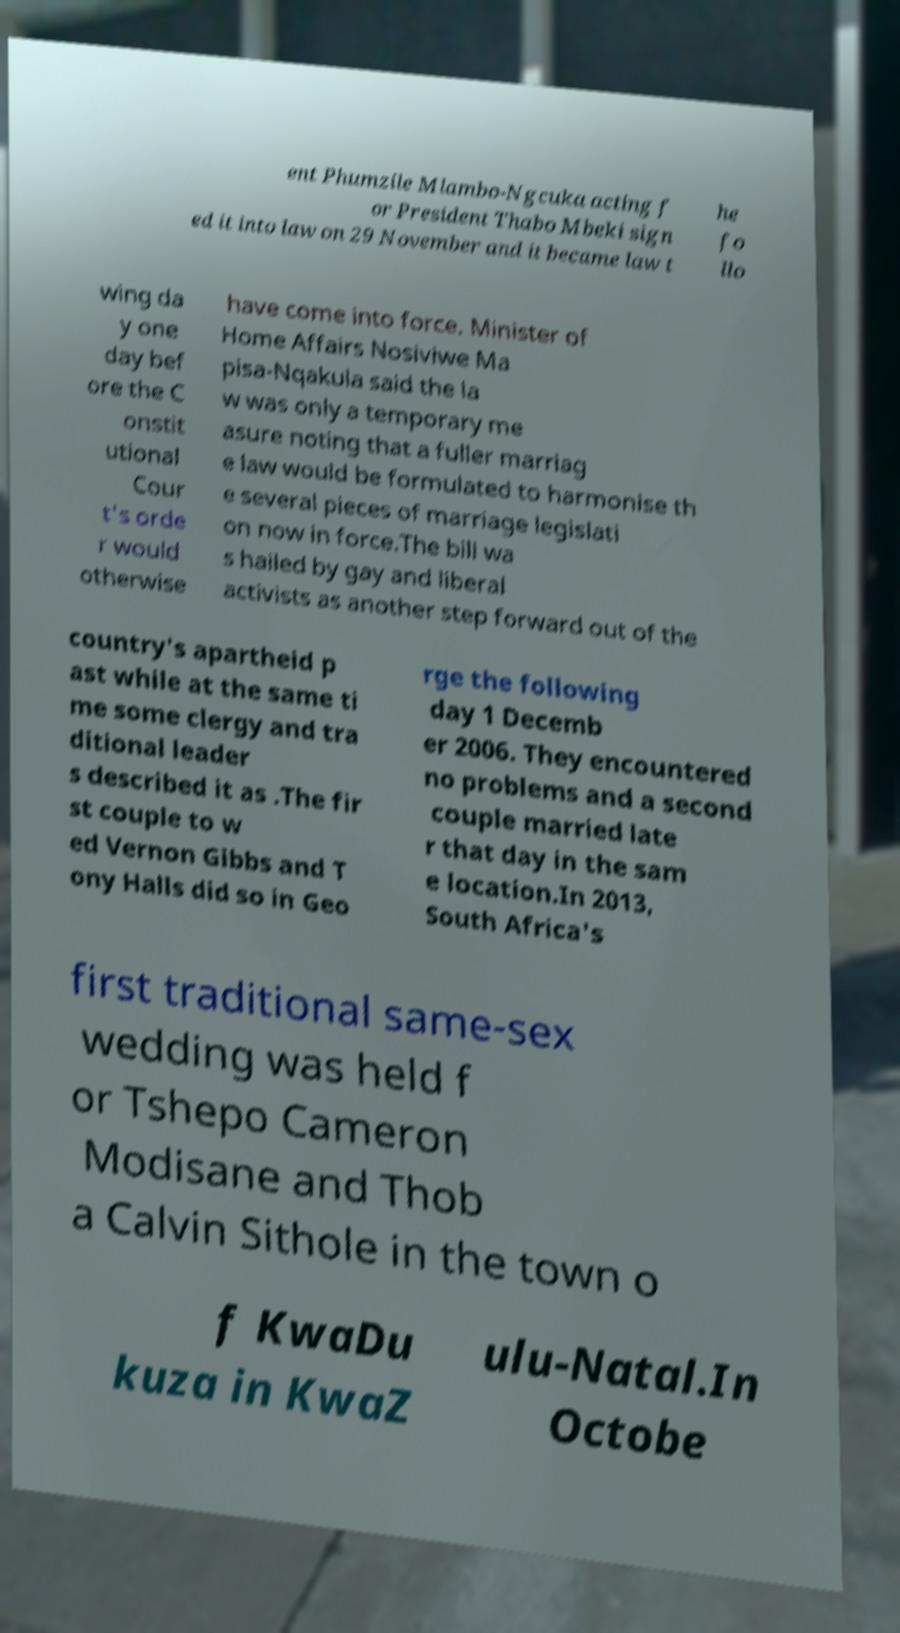Please read and relay the text visible in this image. What does it say? ent Phumzile Mlambo-Ngcuka acting f or President Thabo Mbeki sign ed it into law on 29 November and it became law t he fo llo wing da y one day bef ore the C onstit utional Cour t's orde r would otherwise have come into force. Minister of Home Affairs Nosiviwe Ma pisa-Nqakula said the la w was only a temporary me asure noting that a fuller marriag e law would be formulated to harmonise th e several pieces of marriage legislati on now in force.The bill wa s hailed by gay and liberal activists as another step forward out of the country's apartheid p ast while at the same ti me some clergy and tra ditional leader s described it as .The fir st couple to w ed Vernon Gibbs and T ony Halls did so in Geo rge the following day 1 Decemb er 2006. They encountered no problems and a second couple married late r that day in the sam e location.In 2013, South Africa's first traditional same-sex wedding was held f or Tshepo Cameron Modisane and Thob a Calvin Sithole in the town o f KwaDu kuza in KwaZ ulu-Natal.In Octobe 